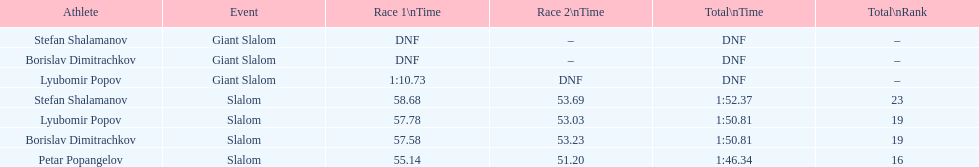What is the ranking number of stefan shalamanov in the slalom event? 23. 